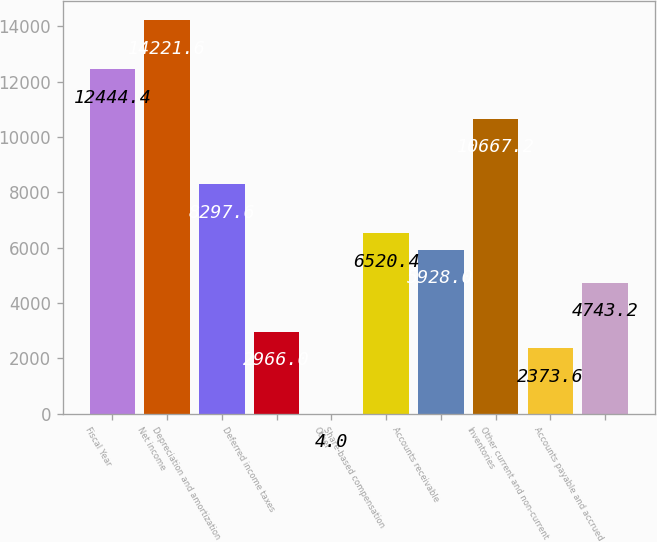Convert chart to OTSL. <chart><loc_0><loc_0><loc_500><loc_500><bar_chart><fcel>Fiscal Year<fcel>Net income<fcel>Depreciation and amortization<fcel>Deferred income taxes<fcel>Other<fcel>Share-based compensation<fcel>Accounts receivable<fcel>Inventories<fcel>Other current and non-current<fcel>Accounts payable and accrued<nl><fcel>12444.4<fcel>14221.6<fcel>8297.6<fcel>2966<fcel>4<fcel>6520.4<fcel>5928<fcel>10667.2<fcel>2373.6<fcel>4743.2<nl></chart> 